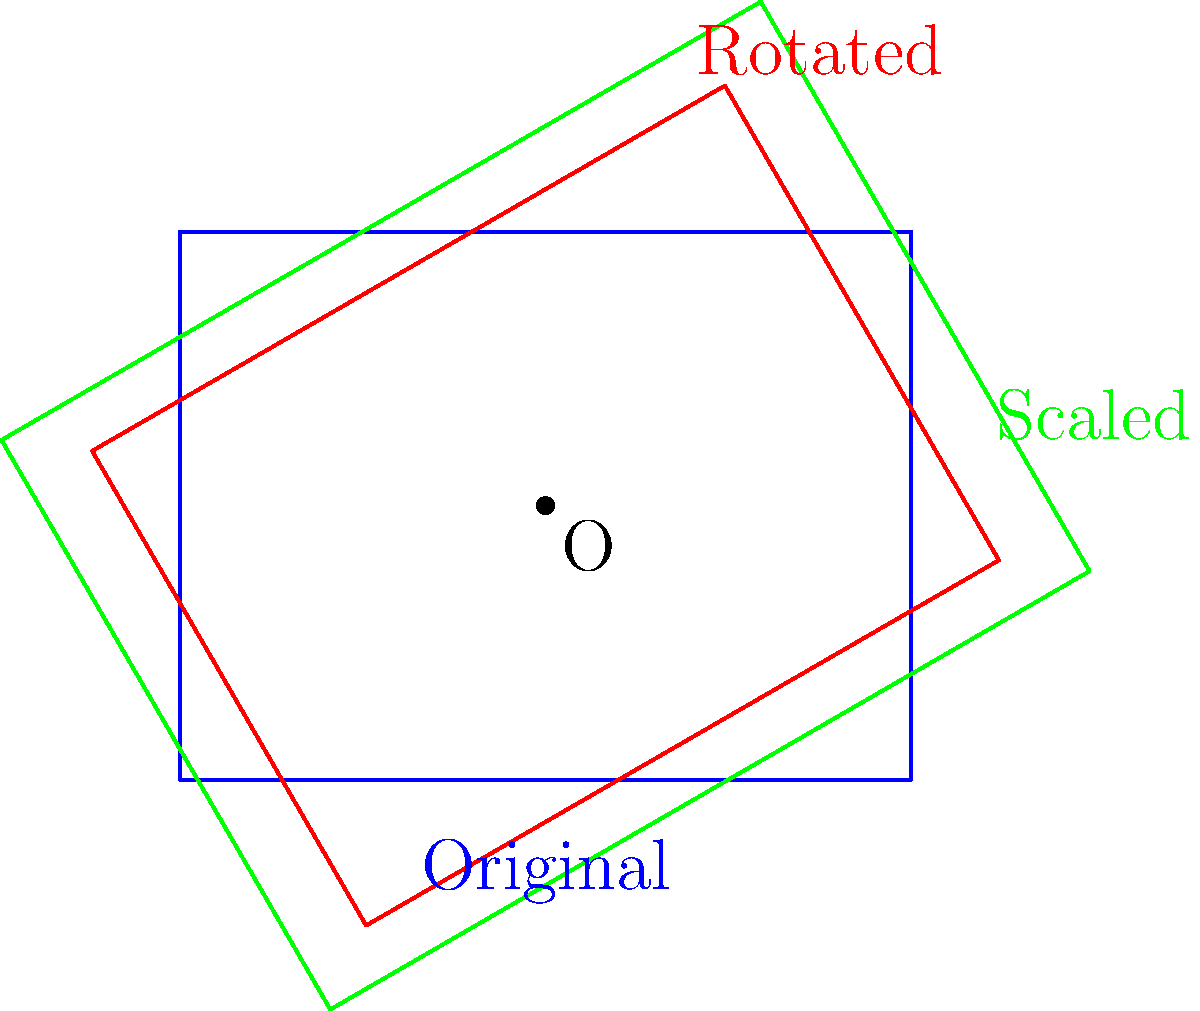A sustainable building design with solar panels is represented by the blue rectangle. To maximize solar panel efficiency, the design is first rotated $30^\circ$ clockwise around point O (shown in red), then scaled by a factor of 1.2 from the same point (shown in green). If the original building had dimensions of 4 units by 3 units, what is the area of the final scaled design? Let's approach this step-by-step:

1) The original area of the building:
   $A_{original} = 4 \times 3 = 12$ square units

2) The rotation doesn't change the area of the shape, so after rotation:
   $A_{rotated} = A_{original} = 12$ square units

3) When we scale a 2D shape by a factor of $k$, its area is multiplied by $k^2$. Here, we're scaling by a factor of 1.2, so:
   $A_{final} = A_{rotated} \times 1.2^2$

4) Let's calculate this:
   $A_{final} = 12 \times 1.2^2 = 12 \times 1.44 = 17.28$ square units

Therefore, the area of the final scaled design is 17.28 square units.
Answer: 17.28 square units 